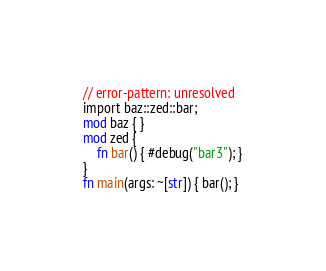Convert code to text. <code><loc_0><loc_0><loc_500><loc_500><_Rust_>// error-pattern: unresolved
import baz::zed::bar;
mod baz { }
mod zed {
    fn bar() { #debug("bar3"); }
}
fn main(args: ~[str]) { bar(); }
</code> 